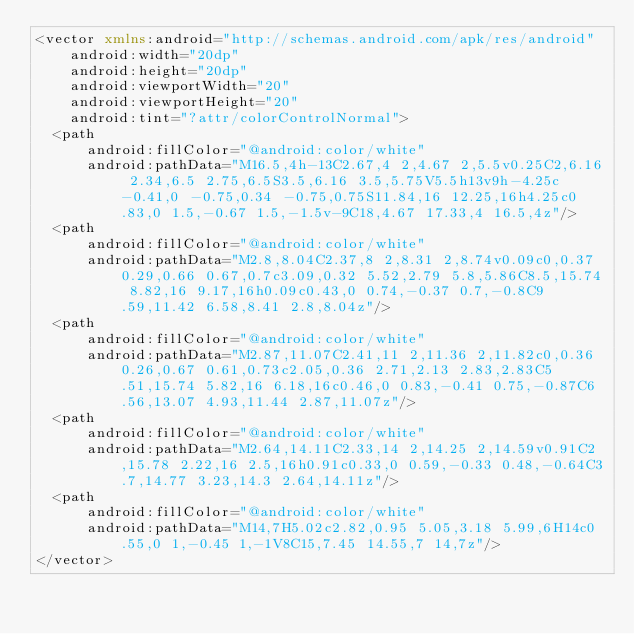<code> <loc_0><loc_0><loc_500><loc_500><_XML_><vector xmlns:android="http://schemas.android.com/apk/res/android"
    android:width="20dp"
    android:height="20dp"
    android:viewportWidth="20"
    android:viewportHeight="20"
    android:tint="?attr/colorControlNormal">
  <path
      android:fillColor="@android:color/white"
      android:pathData="M16.5,4h-13C2.67,4 2,4.67 2,5.5v0.25C2,6.16 2.34,6.5 2.75,6.5S3.5,6.16 3.5,5.75V5.5h13v9h-4.25c-0.41,0 -0.75,0.34 -0.75,0.75S11.84,16 12.25,16h4.25c0.83,0 1.5,-0.67 1.5,-1.5v-9C18,4.67 17.33,4 16.5,4z"/>
  <path
      android:fillColor="@android:color/white"
      android:pathData="M2.8,8.04C2.37,8 2,8.31 2,8.74v0.09c0,0.37 0.29,0.66 0.67,0.7c3.09,0.32 5.52,2.79 5.8,5.86C8.5,15.74 8.82,16 9.17,16h0.09c0.43,0 0.74,-0.37 0.7,-0.8C9.59,11.42 6.58,8.41 2.8,8.04z"/>
  <path
      android:fillColor="@android:color/white"
      android:pathData="M2.87,11.07C2.41,11 2,11.36 2,11.82c0,0.36 0.26,0.67 0.61,0.73c2.05,0.36 2.71,2.13 2.83,2.83C5.51,15.74 5.82,16 6.18,16c0.46,0 0.83,-0.41 0.75,-0.87C6.56,13.07 4.93,11.44 2.87,11.07z"/>
  <path
      android:fillColor="@android:color/white"
      android:pathData="M2.64,14.11C2.33,14 2,14.25 2,14.59v0.91C2,15.78 2.22,16 2.5,16h0.91c0.33,0 0.59,-0.33 0.48,-0.64C3.7,14.77 3.23,14.3 2.64,14.11z"/>
  <path
      android:fillColor="@android:color/white"
      android:pathData="M14,7H5.02c2.82,0.95 5.05,3.18 5.99,6H14c0.55,0 1,-0.45 1,-1V8C15,7.45 14.55,7 14,7z"/>
</vector>
</code> 